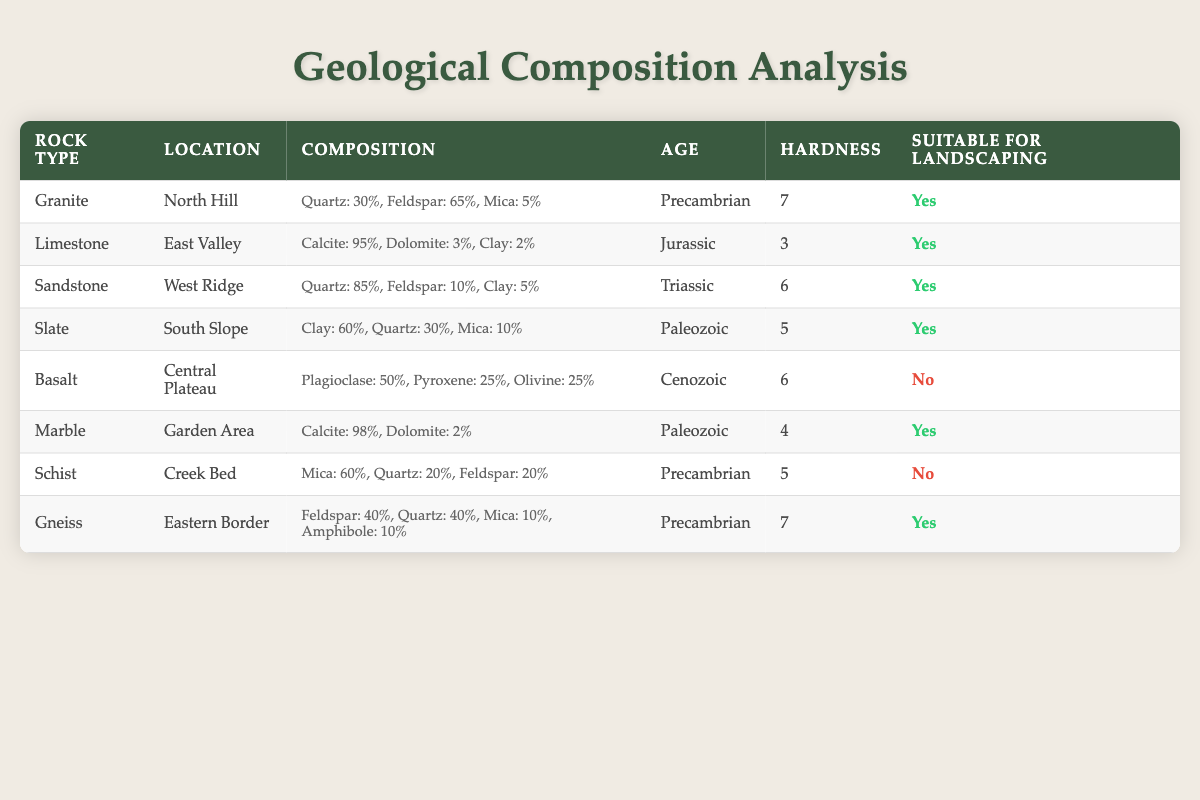What is the hardness of Limestone? The table shows that Limestone has a hardness rating of 3.
Answer: 3 Which rock type has the highest quartz composition? By examining the composition values in the table, Sandstone has the highest quartz percentage at 85%.
Answer: Sandstone Are there any rock types that are not suitable for landscaping? The table indicates that both Basalt and Schist are marked as unsuitable for landscaping.
Answer: Yes What is the average hardness of the rock types suitable for landscaping? The suitable rock types and their hardness ratings are Granite (7), Limestone (3), Sandstone (6), Slate (5), Marble (4), and Gneiss (7). The sum is 32 and there are 6 rock types, so the average is 32/6 = 5.33.
Answer: 5.33 Which rock type is the oldest according to the table? Looking at the age column, the oldest rock type is Granite, which is dated from the Precambrian period.
Answer: Granite How many rock types are from the Paleozoic era? The table lists two rock types from the Paleozoic era: Slate and Marble.
Answer: 2 What is the composition of Granite in percentage? The table provides the composition of Granite as Quartz: 30%, Feldspar: 65%, Mica: 5%.
Answer: Quartz: 30%, Feldspar: 65%, Mica: 5% Is there a rock type in the table with a hardness rating of 6? Yes, both Sandstone and Basalt have a hardness rating of 6.
Answer: Yes What is the total percentage of feldspar in suitable rock types? Suitable rock types and their feldspar composition are Granite (65%), Limestone (0%), Sandstone (10%), Slate (0%), Marble (0%), and Gneiss (40%). The sum is 65 + 0 + 10 + 0 + 0 + 40 = 115%.
Answer: 115% 